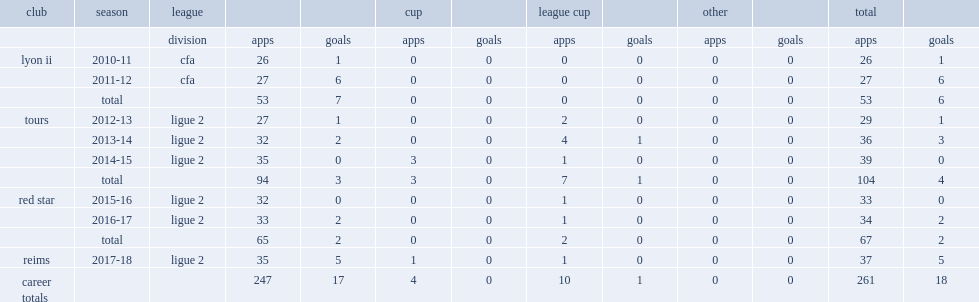Which club did chavalerin play for in 2017-18? Reims. 